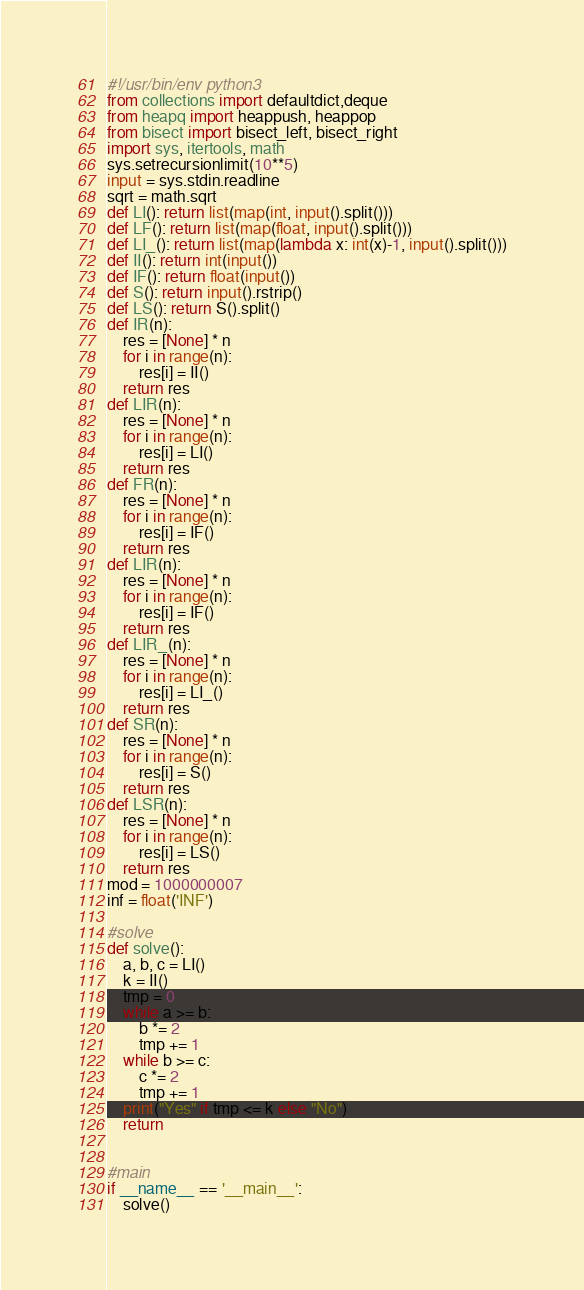Convert code to text. <code><loc_0><loc_0><loc_500><loc_500><_Python_>#!/usr/bin/env python3
from collections import defaultdict,deque
from heapq import heappush, heappop
from bisect import bisect_left, bisect_right
import sys, itertools, math
sys.setrecursionlimit(10**5)
input = sys.stdin.readline
sqrt = math.sqrt
def LI(): return list(map(int, input().split()))
def LF(): return list(map(float, input().split()))
def LI_(): return list(map(lambda x: int(x)-1, input().split()))
def II(): return int(input())
def IF(): return float(input())
def S(): return input().rstrip()
def LS(): return S().split()
def IR(n):
    res = [None] * n
    for i in range(n):
        res[i] = II()
    return res
def LIR(n):
    res = [None] * n
    for i in range(n):
        res[i] = LI()
    return res
def FR(n):
    res = [None] * n
    for i in range(n):
        res[i] = IF()
    return res
def LIR(n):
    res = [None] * n
    for i in range(n):
        res[i] = IF()
    return res
def LIR_(n):
    res = [None] * n
    for i in range(n):
        res[i] = LI_()
    return res
def SR(n):
    res = [None] * n
    for i in range(n):
        res[i] = S()
    return res
def LSR(n):
    res = [None] * n
    for i in range(n):
        res[i] = LS()
    return res
mod = 1000000007
inf = float('INF')

#solve
def solve():
    a, b, c = LI()
    k = II()
    tmp = 0
    while a >= b:
        b *= 2
        tmp += 1
    while b >= c:
        c *= 2
        tmp += 1
    print("Yes" if tmp <= k else "No")
    return


#main
if __name__ == '__main__':
    solve()
</code> 